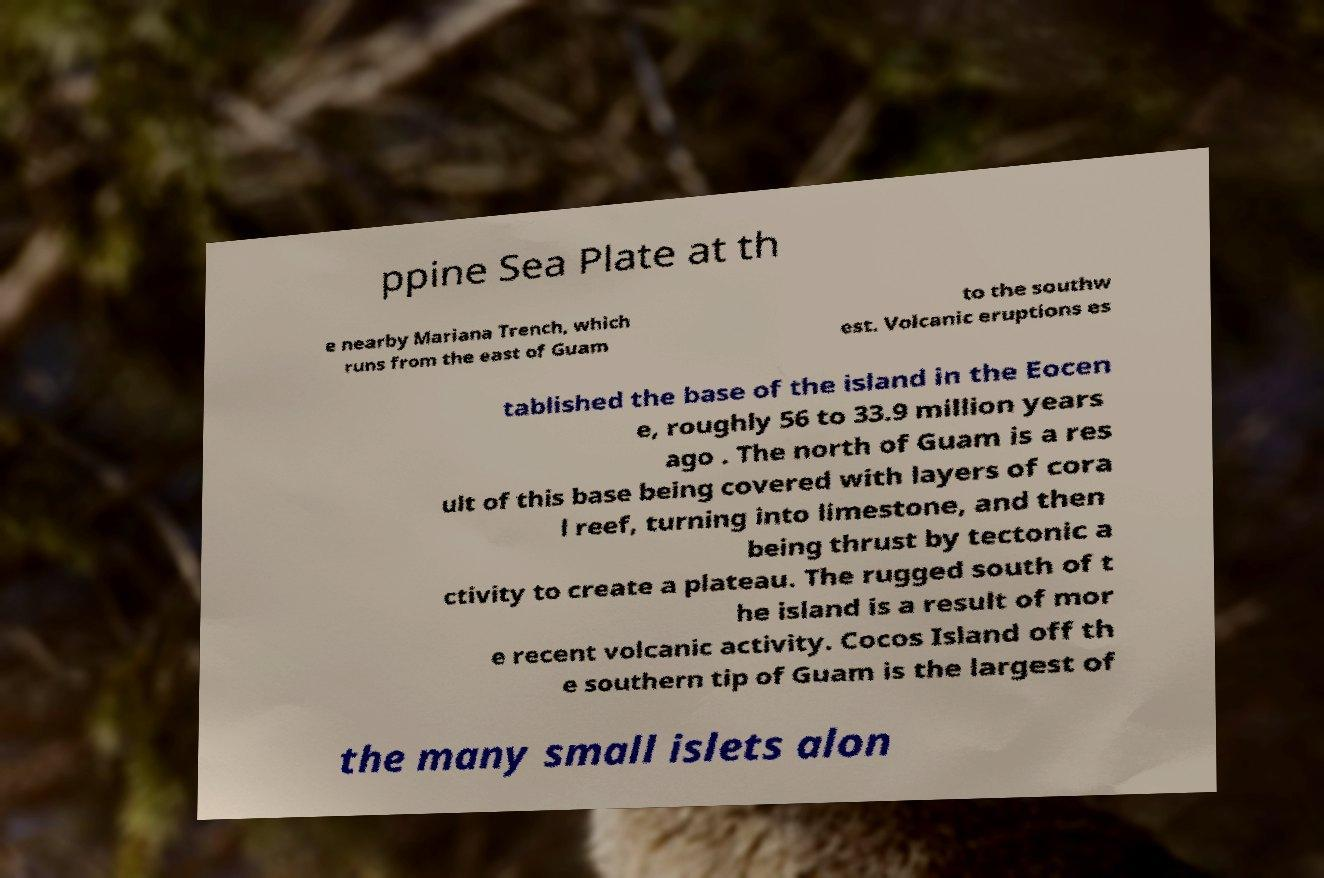There's text embedded in this image that I need extracted. Can you transcribe it verbatim? ppine Sea Plate at th e nearby Mariana Trench, which runs from the east of Guam to the southw est. Volcanic eruptions es tablished the base of the island in the Eocen e, roughly 56 to 33.9 million years ago . The north of Guam is a res ult of this base being covered with layers of cora l reef, turning into limestone, and then being thrust by tectonic a ctivity to create a plateau. The rugged south of t he island is a result of mor e recent volcanic activity. Cocos Island off th e southern tip of Guam is the largest of the many small islets alon 